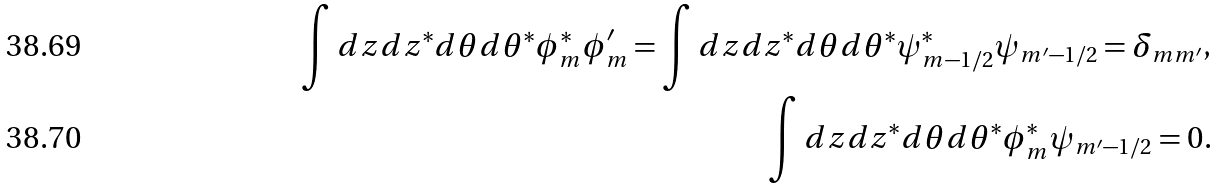<formula> <loc_0><loc_0><loc_500><loc_500>\int d z d z ^ { * } d \theta d \theta ^ { * } \phi _ { m } ^ { * } \phi _ { m } ^ { \prime } = \int d z d z ^ { * } d \theta d \theta ^ { * } \psi _ { m - 1 / 2 } ^ { * } \psi _ { m ^ { \prime } - 1 / 2 } = \delta _ { m m ^ { \prime } } , \\ \int d z d z ^ { * } d \theta d \theta ^ { * } \phi _ { m } ^ { * } \psi _ { m ^ { \prime } - 1 / 2 } = 0 .</formula> 